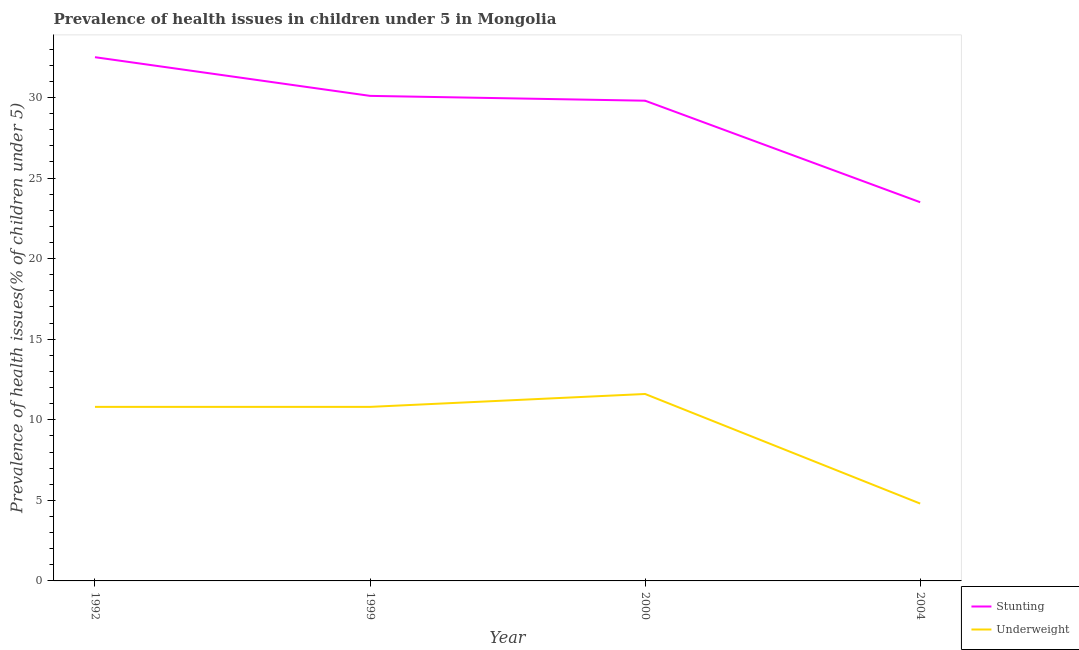How many different coloured lines are there?
Keep it short and to the point. 2. Does the line corresponding to percentage of stunted children intersect with the line corresponding to percentage of underweight children?
Your response must be concise. No. Is the number of lines equal to the number of legend labels?
Keep it short and to the point. Yes. What is the percentage of underweight children in 2000?
Your answer should be compact. 11.6. Across all years, what is the maximum percentage of stunted children?
Offer a very short reply. 32.5. Across all years, what is the minimum percentage of underweight children?
Offer a terse response. 4.8. In which year was the percentage of underweight children maximum?
Offer a very short reply. 2000. In which year was the percentage of stunted children minimum?
Give a very brief answer. 2004. What is the total percentage of underweight children in the graph?
Give a very brief answer. 38. What is the difference between the percentage of underweight children in 2000 and that in 2004?
Ensure brevity in your answer.  6.8. What is the difference between the percentage of underweight children in 2004 and the percentage of stunted children in 1999?
Offer a very short reply. -25.3. What is the average percentage of underweight children per year?
Offer a terse response. 9.5. In the year 2000, what is the difference between the percentage of stunted children and percentage of underweight children?
Provide a succinct answer. 18.2. In how many years, is the percentage of underweight children greater than 24 %?
Give a very brief answer. 0. What is the ratio of the percentage of stunted children in 1992 to that in 2000?
Keep it short and to the point. 1.09. What is the difference between the highest and the second highest percentage of stunted children?
Make the answer very short. 2.4. In how many years, is the percentage of underweight children greater than the average percentage of underweight children taken over all years?
Your answer should be very brief. 3. Is the sum of the percentage of stunted children in 2000 and 2004 greater than the maximum percentage of underweight children across all years?
Give a very brief answer. Yes. Does the percentage of underweight children monotonically increase over the years?
Make the answer very short. No. What is the difference between two consecutive major ticks on the Y-axis?
Your answer should be compact. 5. Does the graph contain any zero values?
Make the answer very short. No. What is the title of the graph?
Offer a terse response. Prevalence of health issues in children under 5 in Mongolia. What is the label or title of the X-axis?
Your answer should be very brief. Year. What is the label or title of the Y-axis?
Keep it short and to the point. Prevalence of health issues(% of children under 5). What is the Prevalence of health issues(% of children under 5) in Stunting in 1992?
Your answer should be very brief. 32.5. What is the Prevalence of health issues(% of children under 5) of Underweight in 1992?
Keep it short and to the point. 10.8. What is the Prevalence of health issues(% of children under 5) of Stunting in 1999?
Your response must be concise. 30.1. What is the Prevalence of health issues(% of children under 5) of Underweight in 1999?
Keep it short and to the point. 10.8. What is the Prevalence of health issues(% of children under 5) of Stunting in 2000?
Keep it short and to the point. 29.8. What is the Prevalence of health issues(% of children under 5) of Underweight in 2000?
Keep it short and to the point. 11.6. What is the Prevalence of health issues(% of children under 5) in Underweight in 2004?
Ensure brevity in your answer.  4.8. Across all years, what is the maximum Prevalence of health issues(% of children under 5) in Stunting?
Provide a succinct answer. 32.5. Across all years, what is the maximum Prevalence of health issues(% of children under 5) in Underweight?
Ensure brevity in your answer.  11.6. Across all years, what is the minimum Prevalence of health issues(% of children under 5) in Stunting?
Keep it short and to the point. 23.5. Across all years, what is the minimum Prevalence of health issues(% of children under 5) in Underweight?
Your response must be concise. 4.8. What is the total Prevalence of health issues(% of children under 5) of Stunting in the graph?
Offer a terse response. 115.9. What is the total Prevalence of health issues(% of children under 5) of Underweight in the graph?
Your response must be concise. 38. What is the difference between the Prevalence of health issues(% of children under 5) in Underweight in 1992 and that in 2000?
Ensure brevity in your answer.  -0.8. What is the difference between the Prevalence of health issues(% of children under 5) of Underweight in 1992 and that in 2004?
Provide a short and direct response. 6. What is the difference between the Prevalence of health issues(% of children under 5) of Stunting in 1999 and that in 2000?
Provide a short and direct response. 0.3. What is the difference between the Prevalence of health issues(% of children under 5) in Stunting in 1992 and the Prevalence of health issues(% of children under 5) in Underweight in 1999?
Offer a very short reply. 21.7. What is the difference between the Prevalence of health issues(% of children under 5) in Stunting in 1992 and the Prevalence of health issues(% of children under 5) in Underweight in 2000?
Provide a succinct answer. 20.9. What is the difference between the Prevalence of health issues(% of children under 5) in Stunting in 1992 and the Prevalence of health issues(% of children under 5) in Underweight in 2004?
Ensure brevity in your answer.  27.7. What is the difference between the Prevalence of health issues(% of children under 5) of Stunting in 1999 and the Prevalence of health issues(% of children under 5) of Underweight in 2004?
Provide a short and direct response. 25.3. What is the average Prevalence of health issues(% of children under 5) of Stunting per year?
Provide a short and direct response. 28.98. In the year 1992, what is the difference between the Prevalence of health issues(% of children under 5) in Stunting and Prevalence of health issues(% of children under 5) in Underweight?
Give a very brief answer. 21.7. In the year 1999, what is the difference between the Prevalence of health issues(% of children under 5) in Stunting and Prevalence of health issues(% of children under 5) in Underweight?
Offer a terse response. 19.3. In the year 2000, what is the difference between the Prevalence of health issues(% of children under 5) in Stunting and Prevalence of health issues(% of children under 5) in Underweight?
Offer a terse response. 18.2. What is the ratio of the Prevalence of health issues(% of children under 5) of Stunting in 1992 to that in 1999?
Offer a very short reply. 1.08. What is the ratio of the Prevalence of health issues(% of children under 5) in Underweight in 1992 to that in 1999?
Your answer should be very brief. 1. What is the ratio of the Prevalence of health issues(% of children under 5) in Stunting in 1992 to that in 2000?
Your answer should be compact. 1.09. What is the ratio of the Prevalence of health issues(% of children under 5) of Underweight in 1992 to that in 2000?
Make the answer very short. 0.93. What is the ratio of the Prevalence of health issues(% of children under 5) in Stunting in 1992 to that in 2004?
Your answer should be very brief. 1.38. What is the ratio of the Prevalence of health issues(% of children under 5) of Underweight in 1992 to that in 2004?
Provide a succinct answer. 2.25. What is the ratio of the Prevalence of health issues(% of children under 5) of Stunting in 1999 to that in 2004?
Give a very brief answer. 1.28. What is the ratio of the Prevalence of health issues(% of children under 5) in Underweight in 1999 to that in 2004?
Keep it short and to the point. 2.25. What is the ratio of the Prevalence of health issues(% of children under 5) of Stunting in 2000 to that in 2004?
Your answer should be very brief. 1.27. What is the ratio of the Prevalence of health issues(% of children under 5) in Underweight in 2000 to that in 2004?
Give a very brief answer. 2.42. What is the difference between the highest and the second highest Prevalence of health issues(% of children under 5) in Stunting?
Offer a very short reply. 2.4. What is the difference between the highest and the second highest Prevalence of health issues(% of children under 5) of Underweight?
Offer a terse response. 0.8. 